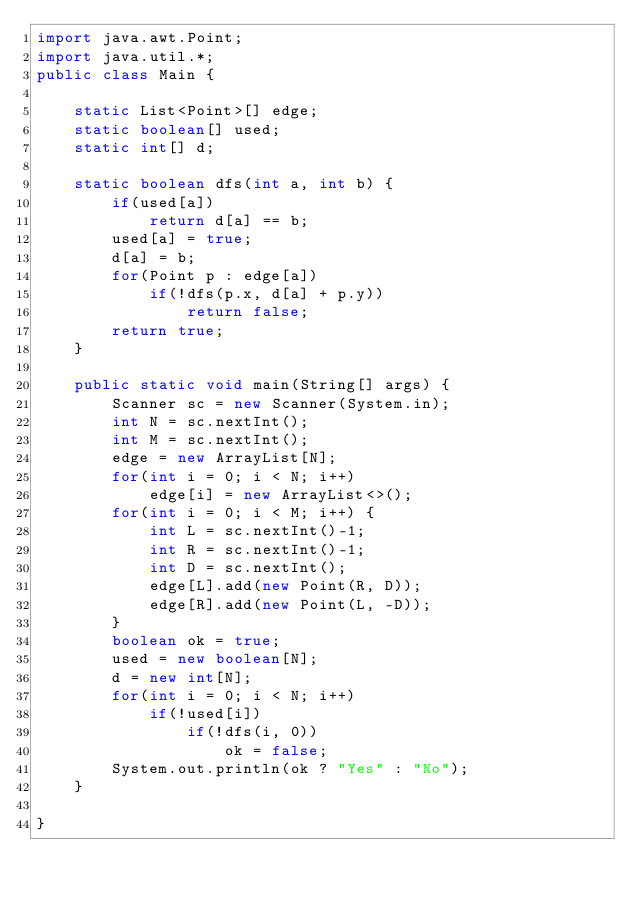Convert code to text. <code><loc_0><loc_0><loc_500><loc_500><_Java_>import java.awt.Point;
import java.util.*;
public class Main {
	
	static List<Point>[] edge;
	static boolean[] used;
	static int[] d;
	
	static boolean dfs(int a, int b) {
		if(used[a])
			return d[a] == b;
		used[a] = true;
		d[a] = b;
		for(Point p : edge[a])
			if(!dfs(p.x, d[a] + p.y))
				return false;
		return true;
	}

	public static void main(String[] args) {
		Scanner sc = new Scanner(System.in);
		int N = sc.nextInt();
		int M = sc.nextInt();
		edge = new ArrayList[N];
		for(int i = 0; i < N; i++)
		    edge[i] = new ArrayList<>();
		for(int i = 0; i < M; i++) {
			int L = sc.nextInt()-1;
			int R = sc.nextInt()-1;
			int D = sc.nextInt();
			edge[L].add(new Point(R, D));
			edge[R].add(new Point(L, -D));
		}
		boolean ok = true;
		used = new boolean[N];
		d = new int[N];
		for(int i = 0; i < N; i++)
			if(!used[i])
				if(!dfs(i, 0))
					ok = false;
		System.out.println(ok ? "Yes" : "No");
	}

}
</code> 